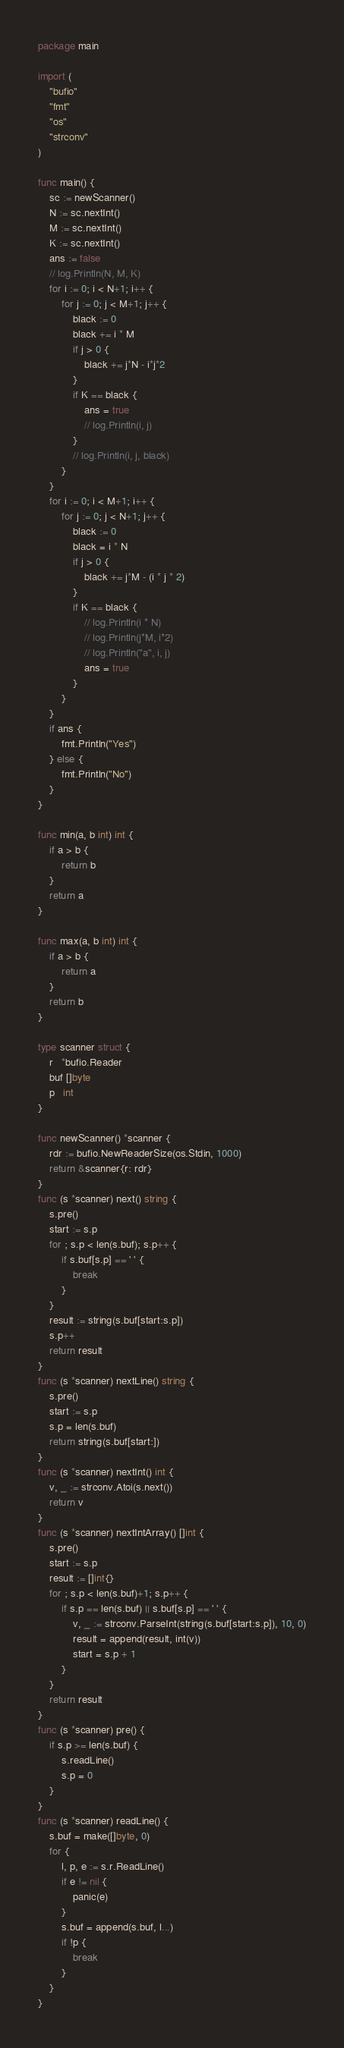<code> <loc_0><loc_0><loc_500><loc_500><_Go_>package main

import (
	"bufio"
	"fmt"
	"os"
	"strconv"
)

func main() {
	sc := newScanner()
	N := sc.nextInt()
	M := sc.nextInt()
	K := sc.nextInt()
	ans := false
	// log.Println(N, M, K)
	for i := 0; i < N+1; i++ {
		for j := 0; j < M+1; j++ {
			black := 0
			black += i * M
			if j > 0 {
				black += j*N - i*j*2
			}
			if K == black {
				ans = true
				// log.Println(i, j)
			}
			// log.Println(i, j, black)
		}
	}
	for i := 0; i < M+1; i++ {
		for j := 0; j < N+1; j++ {
			black := 0
			black = i * N
			if j > 0 {
				black += j*M - (i * j * 2)
			}
			if K == black {
				// log.Println(i * N)
				// log.Println(j*M, i*2)
				// log.Println("a", i, j)
				ans = true
			}
		}
	}
	if ans {
		fmt.Println("Yes")
	} else {
		fmt.Println("No")
	}
}

func min(a, b int) int {
	if a > b {
		return b
	}
	return a
}

func max(a, b int) int {
	if a > b {
		return a
	}
	return b
}

type scanner struct {
	r   *bufio.Reader
	buf []byte
	p   int
}

func newScanner() *scanner {
	rdr := bufio.NewReaderSize(os.Stdin, 1000)
	return &scanner{r: rdr}
}
func (s *scanner) next() string {
	s.pre()
	start := s.p
	for ; s.p < len(s.buf); s.p++ {
		if s.buf[s.p] == ' ' {
			break
		}
	}
	result := string(s.buf[start:s.p])
	s.p++
	return result
}
func (s *scanner) nextLine() string {
	s.pre()
	start := s.p
	s.p = len(s.buf)
	return string(s.buf[start:])
}
func (s *scanner) nextInt() int {
	v, _ := strconv.Atoi(s.next())
	return v
}
func (s *scanner) nextIntArray() []int {
	s.pre()
	start := s.p
	result := []int{}
	for ; s.p < len(s.buf)+1; s.p++ {
		if s.p == len(s.buf) || s.buf[s.p] == ' ' {
			v, _ := strconv.ParseInt(string(s.buf[start:s.p]), 10, 0)
			result = append(result, int(v))
			start = s.p + 1
		}
	}
	return result
}
func (s *scanner) pre() {
	if s.p >= len(s.buf) {
		s.readLine()
		s.p = 0
	}
}
func (s *scanner) readLine() {
	s.buf = make([]byte, 0)
	for {
		l, p, e := s.r.ReadLine()
		if e != nil {
			panic(e)
		}
		s.buf = append(s.buf, l...)
		if !p {
			break
		}
	}
}
</code> 